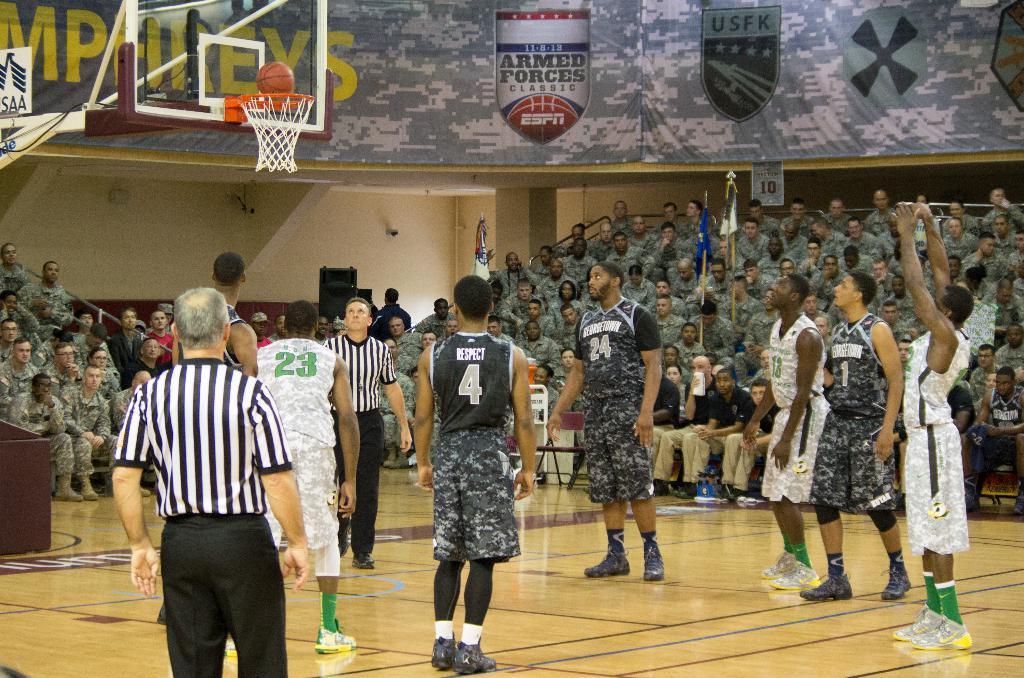Describe this image in one or two sentences. In this picture there are people in the center of the image, they are playing basket ball and there are other people those who are sitting on the chairs as audience in the background area of the image. 